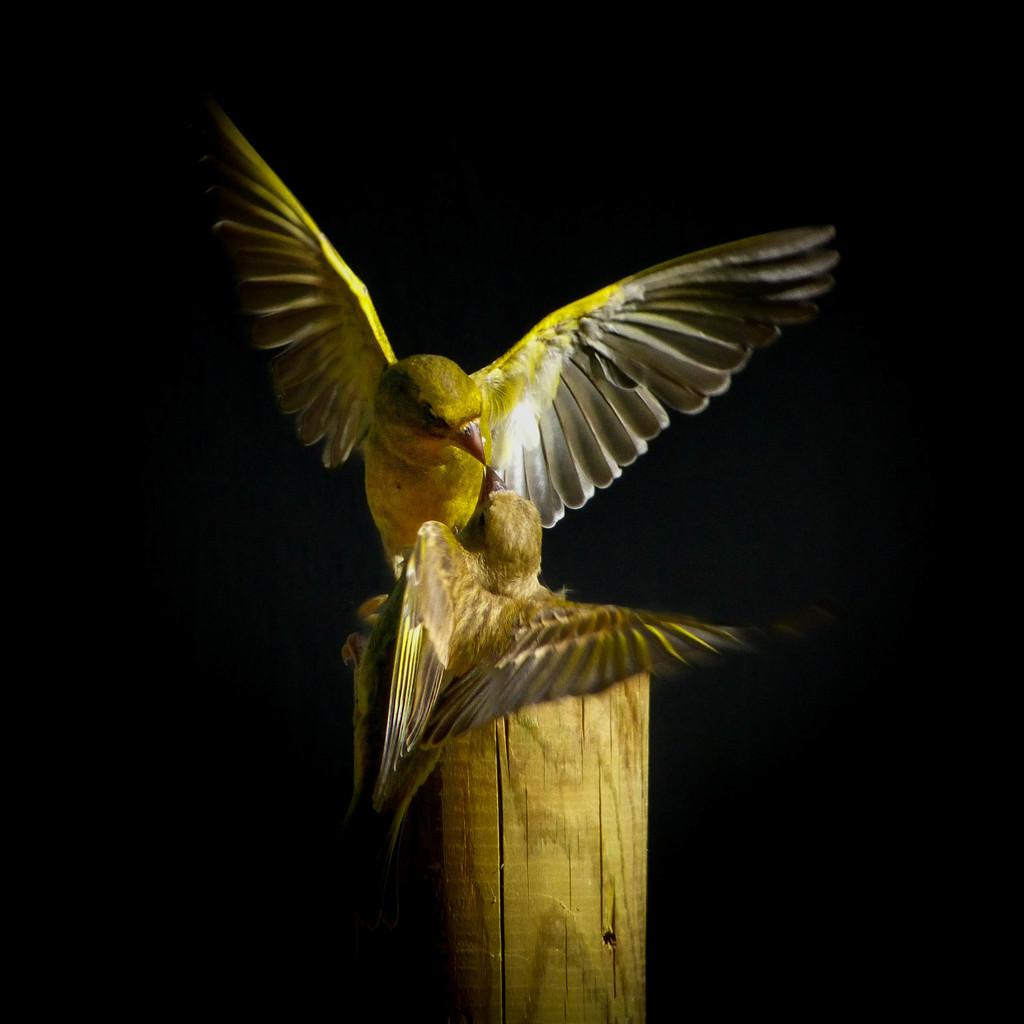What animals are in the center of the image? There are two birds in the center of the image. What object is at the bottom of the image? There is a log at the bottom of the image. Where is the harbor located in the image? There is no harbor present in the image. What type of pets are visible in the image? There are no pets visible in the image; only birds are present. 